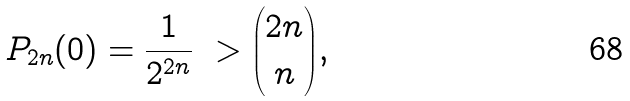Convert formula to latex. <formula><loc_0><loc_0><loc_500><loc_500>P _ { 2 n } ( 0 ) = \frac { 1 } { 2 ^ { 2 n } } \ > { 2 n \choose n } ,</formula> 